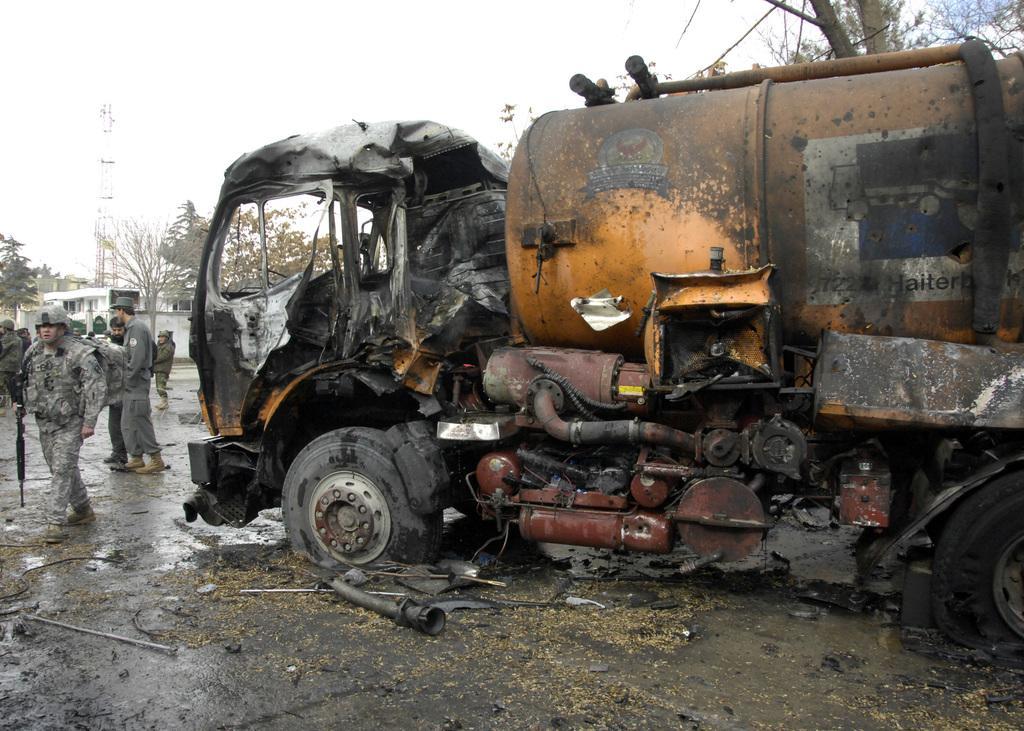Can you describe this image briefly? This looks like a vehicle, which is damaged. I can see groups of people standing. This looks like a building. I can see the trees. This looks like a tower. 